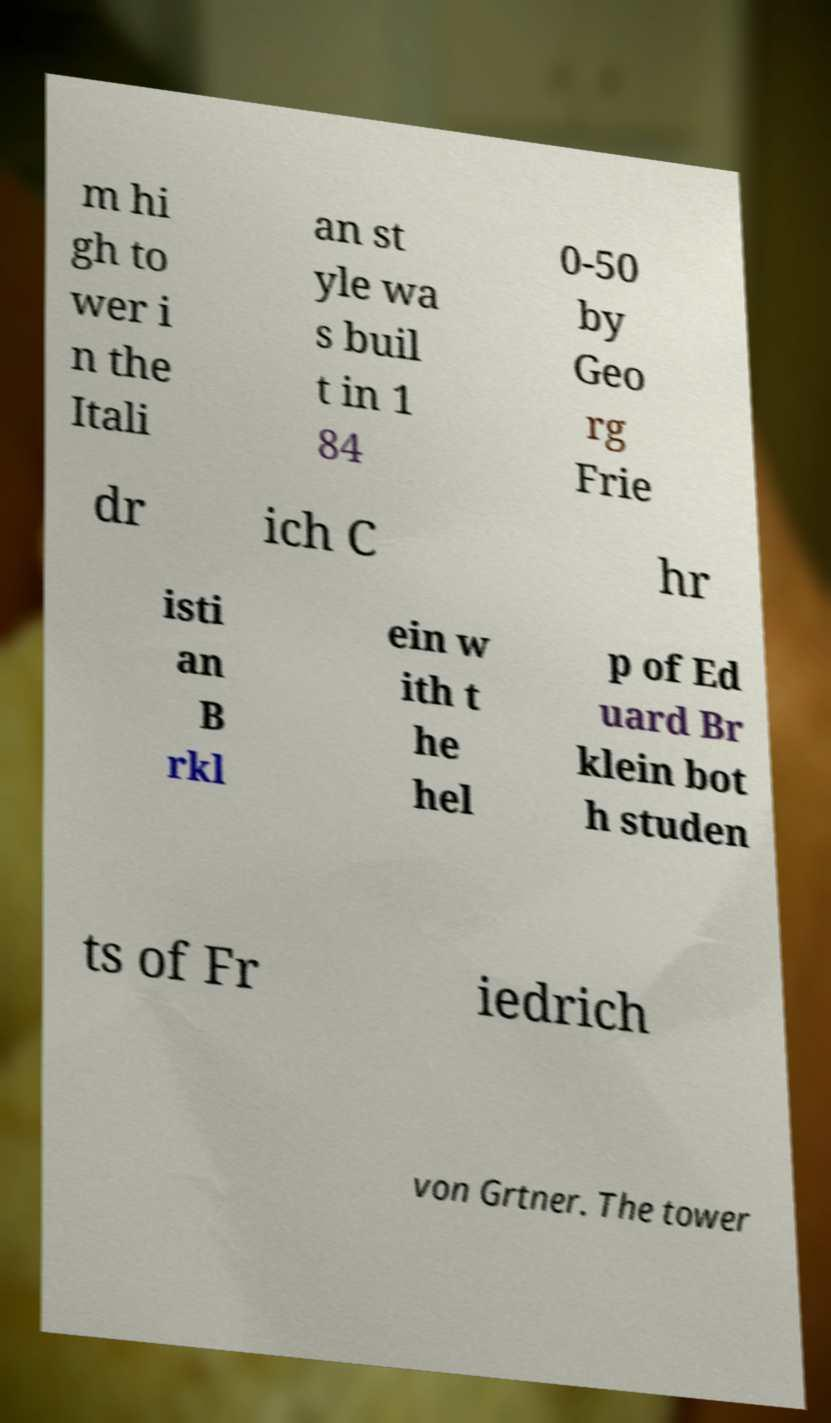Please read and relay the text visible in this image. What does it say? m hi gh to wer i n the Itali an st yle wa s buil t in 1 84 0-50 by Geo rg Frie dr ich C hr isti an B rkl ein w ith t he hel p of Ed uard Br klein bot h studen ts of Fr iedrich von Grtner. The tower 